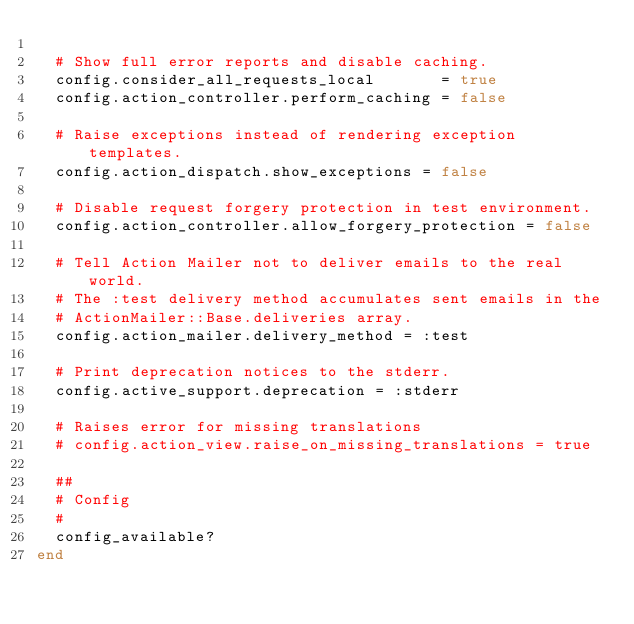Convert code to text. <code><loc_0><loc_0><loc_500><loc_500><_Ruby_>
  # Show full error reports and disable caching.
  config.consider_all_requests_local       = true
  config.action_controller.perform_caching = false

  # Raise exceptions instead of rendering exception templates.
  config.action_dispatch.show_exceptions = false

  # Disable request forgery protection in test environment.
  config.action_controller.allow_forgery_protection = false

  # Tell Action Mailer not to deliver emails to the real world.
  # The :test delivery method accumulates sent emails in the
  # ActionMailer::Base.deliveries array.
  config.action_mailer.delivery_method = :test

  # Print deprecation notices to the stderr.
  config.active_support.deprecation = :stderr

  # Raises error for missing translations
  # config.action_view.raise_on_missing_translations = true

  ##
  # Config
  #
  config_available?
end
</code> 